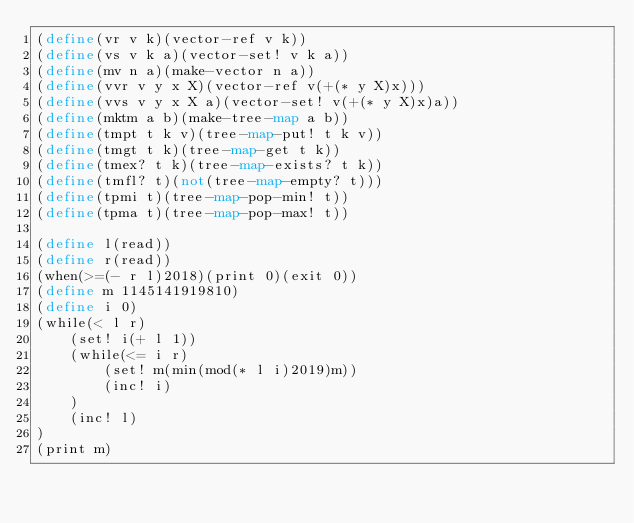Convert code to text. <code><loc_0><loc_0><loc_500><loc_500><_Scheme_>(define(vr v k)(vector-ref v k))
(define(vs v k a)(vector-set! v k a))
(define(mv n a)(make-vector n a))
(define(vvr v y x X)(vector-ref v(+(* y X)x)))
(define(vvs v y x X a)(vector-set! v(+(* y X)x)a))
(define(mktm a b)(make-tree-map a b))
(define(tmpt t k v)(tree-map-put! t k v))
(define(tmgt t k)(tree-map-get t k))
(define(tmex? t k)(tree-map-exists? t k))
(define(tmfl? t)(not(tree-map-empty? t)))
(define(tpmi t)(tree-map-pop-min! t))
(define(tpma t)(tree-map-pop-max! t))

(define l(read))
(define r(read))
(when(>=(- r l)2018)(print 0)(exit 0))
(define m 1145141919810)
(define i 0)
(while(< l r)
	(set! i(+ l 1))
	(while(<= i r)
		(set! m(min(mod(* l i)2019)m))
		(inc! i)
	)
	(inc! l)
)
(print m)</code> 